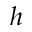<formula> <loc_0><loc_0><loc_500><loc_500>h</formula> 